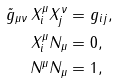<formula> <loc_0><loc_0><loc_500><loc_500>\tilde { g } _ { \mu \nu } \, X ^ { \mu } _ { i } X ^ { \nu } _ { j } & = g _ { i j } , \\ X ^ { \mu } _ { i } N _ { \mu } & = 0 , \\ N ^ { \mu } N _ { \mu } & = 1 ,</formula> 